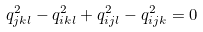Convert formula to latex. <formula><loc_0><loc_0><loc_500><loc_500>q _ { j k l } ^ { 2 } - q _ { i k l } ^ { 2 } + q _ { i j l } ^ { 2 } - q _ { i j k } ^ { 2 } = 0</formula> 